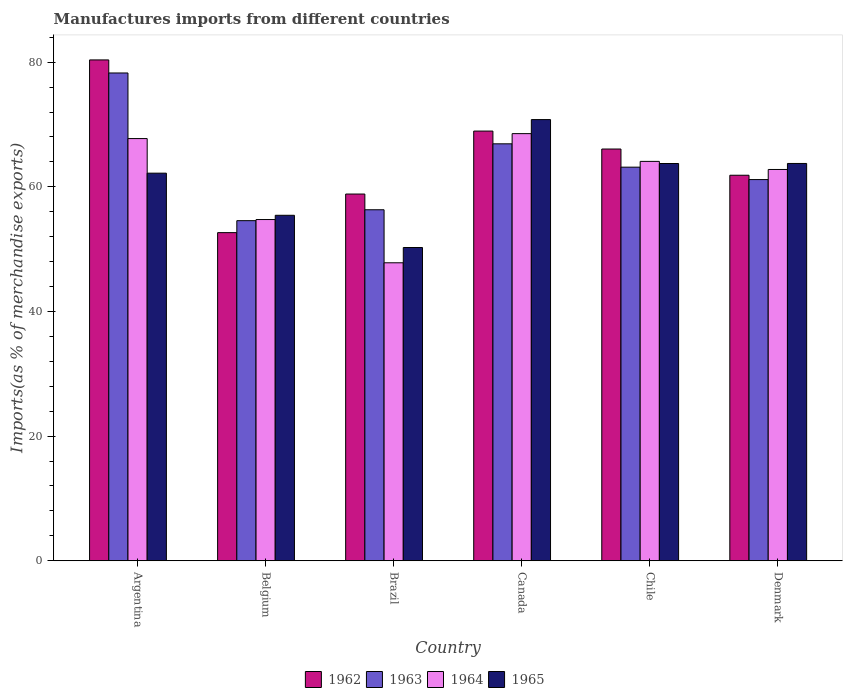How many groups of bars are there?
Make the answer very short. 6. Are the number of bars per tick equal to the number of legend labels?
Your answer should be compact. Yes. How many bars are there on the 4th tick from the left?
Give a very brief answer. 4. How many bars are there on the 1st tick from the right?
Offer a very short reply. 4. What is the percentage of imports to different countries in 1964 in Argentina?
Your response must be concise. 67.75. Across all countries, what is the maximum percentage of imports to different countries in 1963?
Provide a succinct answer. 78.27. Across all countries, what is the minimum percentage of imports to different countries in 1963?
Make the answer very short. 54.57. What is the total percentage of imports to different countries in 1965 in the graph?
Offer a terse response. 366.19. What is the difference between the percentage of imports to different countries in 1964 in Argentina and that in Denmark?
Your response must be concise. 4.96. What is the difference between the percentage of imports to different countries in 1964 in Brazil and the percentage of imports to different countries in 1962 in Chile?
Ensure brevity in your answer.  -18.25. What is the average percentage of imports to different countries in 1963 per country?
Your answer should be very brief. 63.4. What is the difference between the percentage of imports to different countries of/in 1964 and percentage of imports to different countries of/in 1965 in Argentina?
Offer a very short reply. 5.55. What is the ratio of the percentage of imports to different countries in 1962 in Argentina to that in Denmark?
Ensure brevity in your answer.  1.3. Is the percentage of imports to different countries in 1962 in Brazil less than that in Chile?
Give a very brief answer. Yes. Is the difference between the percentage of imports to different countries in 1964 in Brazil and Chile greater than the difference between the percentage of imports to different countries in 1965 in Brazil and Chile?
Your response must be concise. No. What is the difference between the highest and the second highest percentage of imports to different countries in 1965?
Keep it short and to the point. -7.05. What is the difference between the highest and the lowest percentage of imports to different countries in 1964?
Provide a short and direct response. 20.72. What does the 4th bar from the left in Brazil represents?
Make the answer very short. 1965. Is it the case that in every country, the sum of the percentage of imports to different countries in 1963 and percentage of imports to different countries in 1962 is greater than the percentage of imports to different countries in 1964?
Give a very brief answer. Yes. How many bars are there?
Make the answer very short. 24. How many countries are there in the graph?
Your answer should be compact. 6. What is the difference between two consecutive major ticks on the Y-axis?
Your answer should be compact. 20. How are the legend labels stacked?
Provide a short and direct response. Horizontal. What is the title of the graph?
Provide a short and direct response. Manufactures imports from different countries. Does "1997" appear as one of the legend labels in the graph?
Keep it short and to the point. No. What is the label or title of the Y-axis?
Offer a very short reply. Imports(as % of merchandise exports). What is the Imports(as % of merchandise exports) of 1962 in Argentina?
Your response must be concise. 80.37. What is the Imports(as % of merchandise exports) of 1963 in Argentina?
Your response must be concise. 78.27. What is the Imports(as % of merchandise exports) of 1964 in Argentina?
Offer a very short reply. 67.75. What is the Imports(as % of merchandise exports) of 1965 in Argentina?
Provide a succinct answer. 62.19. What is the Imports(as % of merchandise exports) of 1962 in Belgium?
Keep it short and to the point. 52.65. What is the Imports(as % of merchandise exports) in 1963 in Belgium?
Your answer should be compact. 54.57. What is the Imports(as % of merchandise exports) of 1964 in Belgium?
Keep it short and to the point. 54.75. What is the Imports(as % of merchandise exports) in 1965 in Belgium?
Ensure brevity in your answer.  55.44. What is the Imports(as % of merchandise exports) of 1962 in Brazil?
Offer a very short reply. 58.85. What is the Imports(as % of merchandise exports) in 1963 in Brazil?
Make the answer very short. 56.32. What is the Imports(as % of merchandise exports) of 1964 in Brazil?
Make the answer very short. 47.82. What is the Imports(as % of merchandise exports) of 1965 in Brazil?
Provide a short and direct response. 50.27. What is the Imports(as % of merchandise exports) in 1962 in Canada?
Provide a short and direct response. 68.95. What is the Imports(as % of merchandise exports) in 1963 in Canada?
Make the answer very short. 66.9. What is the Imports(as % of merchandise exports) in 1964 in Canada?
Provide a short and direct response. 68.54. What is the Imports(as % of merchandise exports) in 1965 in Canada?
Provide a succinct answer. 70.79. What is the Imports(as % of merchandise exports) in 1962 in Chile?
Offer a terse response. 66.07. What is the Imports(as % of merchandise exports) of 1963 in Chile?
Give a very brief answer. 63.16. What is the Imports(as % of merchandise exports) of 1964 in Chile?
Your answer should be compact. 64.09. What is the Imports(as % of merchandise exports) in 1965 in Chile?
Your answer should be very brief. 63.74. What is the Imports(as % of merchandise exports) of 1962 in Denmark?
Keep it short and to the point. 61.86. What is the Imports(as % of merchandise exports) of 1963 in Denmark?
Give a very brief answer. 61.17. What is the Imports(as % of merchandise exports) in 1964 in Denmark?
Offer a very short reply. 62.79. What is the Imports(as % of merchandise exports) of 1965 in Denmark?
Keep it short and to the point. 63.75. Across all countries, what is the maximum Imports(as % of merchandise exports) in 1962?
Ensure brevity in your answer.  80.37. Across all countries, what is the maximum Imports(as % of merchandise exports) in 1963?
Keep it short and to the point. 78.27. Across all countries, what is the maximum Imports(as % of merchandise exports) of 1964?
Make the answer very short. 68.54. Across all countries, what is the maximum Imports(as % of merchandise exports) of 1965?
Your response must be concise. 70.79. Across all countries, what is the minimum Imports(as % of merchandise exports) in 1962?
Keep it short and to the point. 52.65. Across all countries, what is the minimum Imports(as % of merchandise exports) in 1963?
Your answer should be very brief. 54.57. Across all countries, what is the minimum Imports(as % of merchandise exports) in 1964?
Make the answer very short. 47.82. Across all countries, what is the minimum Imports(as % of merchandise exports) in 1965?
Offer a very short reply. 50.27. What is the total Imports(as % of merchandise exports) of 1962 in the graph?
Provide a succinct answer. 388.75. What is the total Imports(as % of merchandise exports) in 1963 in the graph?
Your answer should be compact. 380.39. What is the total Imports(as % of merchandise exports) in 1964 in the graph?
Ensure brevity in your answer.  365.72. What is the total Imports(as % of merchandise exports) of 1965 in the graph?
Offer a terse response. 366.19. What is the difference between the Imports(as % of merchandise exports) of 1962 in Argentina and that in Belgium?
Offer a very short reply. 27.71. What is the difference between the Imports(as % of merchandise exports) in 1963 in Argentina and that in Belgium?
Provide a succinct answer. 23.7. What is the difference between the Imports(as % of merchandise exports) in 1964 in Argentina and that in Belgium?
Give a very brief answer. 12.99. What is the difference between the Imports(as % of merchandise exports) in 1965 in Argentina and that in Belgium?
Provide a short and direct response. 6.76. What is the difference between the Imports(as % of merchandise exports) in 1962 in Argentina and that in Brazil?
Give a very brief answer. 21.52. What is the difference between the Imports(as % of merchandise exports) in 1963 in Argentina and that in Brazil?
Offer a terse response. 21.95. What is the difference between the Imports(as % of merchandise exports) of 1964 in Argentina and that in Brazil?
Your response must be concise. 19.93. What is the difference between the Imports(as % of merchandise exports) of 1965 in Argentina and that in Brazil?
Your answer should be very brief. 11.93. What is the difference between the Imports(as % of merchandise exports) in 1962 in Argentina and that in Canada?
Make the answer very short. 11.42. What is the difference between the Imports(as % of merchandise exports) in 1963 in Argentina and that in Canada?
Ensure brevity in your answer.  11.37. What is the difference between the Imports(as % of merchandise exports) of 1964 in Argentina and that in Canada?
Provide a succinct answer. -0.79. What is the difference between the Imports(as % of merchandise exports) in 1965 in Argentina and that in Canada?
Provide a succinct answer. -8.6. What is the difference between the Imports(as % of merchandise exports) of 1962 in Argentina and that in Chile?
Your answer should be very brief. 14.3. What is the difference between the Imports(as % of merchandise exports) in 1963 in Argentina and that in Chile?
Offer a terse response. 15.11. What is the difference between the Imports(as % of merchandise exports) of 1964 in Argentina and that in Chile?
Offer a terse response. 3.66. What is the difference between the Imports(as % of merchandise exports) of 1965 in Argentina and that in Chile?
Provide a short and direct response. -1.55. What is the difference between the Imports(as % of merchandise exports) in 1962 in Argentina and that in Denmark?
Your response must be concise. 18.5. What is the difference between the Imports(as % of merchandise exports) in 1963 in Argentina and that in Denmark?
Offer a very short reply. 17.1. What is the difference between the Imports(as % of merchandise exports) in 1964 in Argentina and that in Denmark?
Give a very brief answer. 4.96. What is the difference between the Imports(as % of merchandise exports) of 1965 in Argentina and that in Denmark?
Give a very brief answer. -1.56. What is the difference between the Imports(as % of merchandise exports) of 1962 in Belgium and that in Brazil?
Your answer should be compact. -6.19. What is the difference between the Imports(as % of merchandise exports) of 1963 in Belgium and that in Brazil?
Make the answer very short. -1.75. What is the difference between the Imports(as % of merchandise exports) of 1964 in Belgium and that in Brazil?
Your answer should be very brief. 6.94. What is the difference between the Imports(as % of merchandise exports) in 1965 in Belgium and that in Brazil?
Provide a succinct answer. 5.17. What is the difference between the Imports(as % of merchandise exports) in 1962 in Belgium and that in Canada?
Provide a short and direct response. -16.3. What is the difference between the Imports(as % of merchandise exports) of 1963 in Belgium and that in Canada?
Make the answer very short. -12.33. What is the difference between the Imports(as % of merchandise exports) in 1964 in Belgium and that in Canada?
Your answer should be very brief. -13.78. What is the difference between the Imports(as % of merchandise exports) in 1965 in Belgium and that in Canada?
Ensure brevity in your answer.  -15.36. What is the difference between the Imports(as % of merchandise exports) in 1962 in Belgium and that in Chile?
Keep it short and to the point. -13.41. What is the difference between the Imports(as % of merchandise exports) in 1963 in Belgium and that in Chile?
Keep it short and to the point. -8.59. What is the difference between the Imports(as % of merchandise exports) in 1964 in Belgium and that in Chile?
Make the answer very short. -9.33. What is the difference between the Imports(as % of merchandise exports) of 1965 in Belgium and that in Chile?
Give a very brief answer. -8.31. What is the difference between the Imports(as % of merchandise exports) in 1962 in Belgium and that in Denmark?
Your response must be concise. -9.21. What is the difference between the Imports(as % of merchandise exports) in 1963 in Belgium and that in Denmark?
Provide a short and direct response. -6.59. What is the difference between the Imports(as % of merchandise exports) of 1964 in Belgium and that in Denmark?
Your response must be concise. -8.03. What is the difference between the Imports(as % of merchandise exports) of 1965 in Belgium and that in Denmark?
Provide a succinct answer. -8.32. What is the difference between the Imports(as % of merchandise exports) of 1962 in Brazil and that in Canada?
Provide a short and direct response. -10.1. What is the difference between the Imports(as % of merchandise exports) of 1963 in Brazil and that in Canada?
Your answer should be compact. -10.58. What is the difference between the Imports(as % of merchandise exports) of 1964 in Brazil and that in Canada?
Your answer should be compact. -20.72. What is the difference between the Imports(as % of merchandise exports) of 1965 in Brazil and that in Canada?
Keep it short and to the point. -20.53. What is the difference between the Imports(as % of merchandise exports) in 1962 in Brazil and that in Chile?
Offer a very short reply. -7.22. What is the difference between the Imports(as % of merchandise exports) of 1963 in Brazil and that in Chile?
Make the answer very short. -6.84. What is the difference between the Imports(as % of merchandise exports) of 1964 in Brazil and that in Chile?
Your response must be concise. -16.27. What is the difference between the Imports(as % of merchandise exports) in 1965 in Brazil and that in Chile?
Offer a very short reply. -13.48. What is the difference between the Imports(as % of merchandise exports) of 1962 in Brazil and that in Denmark?
Your answer should be very brief. -3.01. What is the difference between the Imports(as % of merchandise exports) in 1963 in Brazil and that in Denmark?
Your answer should be compact. -4.84. What is the difference between the Imports(as % of merchandise exports) in 1964 in Brazil and that in Denmark?
Make the answer very short. -14.97. What is the difference between the Imports(as % of merchandise exports) in 1965 in Brazil and that in Denmark?
Offer a terse response. -13.49. What is the difference between the Imports(as % of merchandise exports) in 1962 in Canada and that in Chile?
Provide a short and direct response. 2.88. What is the difference between the Imports(as % of merchandise exports) in 1963 in Canada and that in Chile?
Offer a very short reply. 3.74. What is the difference between the Imports(as % of merchandise exports) in 1964 in Canada and that in Chile?
Keep it short and to the point. 4.45. What is the difference between the Imports(as % of merchandise exports) in 1965 in Canada and that in Chile?
Your response must be concise. 7.05. What is the difference between the Imports(as % of merchandise exports) in 1962 in Canada and that in Denmark?
Your answer should be compact. 7.09. What is the difference between the Imports(as % of merchandise exports) in 1963 in Canada and that in Denmark?
Your response must be concise. 5.74. What is the difference between the Imports(as % of merchandise exports) in 1964 in Canada and that in Denmark?
Give a very brief answer. 5.75. What is the difference between the Imports(as % of merchandise exports) in 1965 in Canada and that in Denmark?
Your response must be concise. 7.04. What is the difference between the Imports(as % of merchandise exports) of 1962 in Chile and that in Denmark?
Provide a succinct answer. 4.21. What is the difference between the Imports(as % of merchandise exports) of 1963 in Chile and that in Denmark?
Offer a very short reply. 1.99. What is the difference between the Imports(as % of merchandise exports) of 1964 in Chile and that in Denmark?
Offer a terse response. 1.3. What is the difference between the Imports(as % of merchandise exports) in 1965 in Chile and that in Denmark?
Your response must be concise. -0.01. What is the difference between the Imports(as % of merchandise exports) of 1962 in Argentina and the Imports(as % of merchandise exports) of 1963 in Belgium?
Provide a short and direct response. 25.79. What is the difference between the Imports(as % of merchandise exports) of 1962 in Argentina and the Imports(as % of merchandise exports) of 1964 in Belgium?
Provide a short and direct response. 25.61. What is the difference between the Imports(as % of merchandise exports) in 1962 in Argentina and the Imports(as % of merchandise exports) in 1965 in Belgium?
Make the answer very short. 24.93. What is the difference between the Imports(as % of merchandise exports) of 1963 in Argentina and the Imports(as % of merchandise exports) of 1964 in Belgium?
Offer a very short reply. 23.52. What is the difference between the Imports(as % of merchandise exports) in 1963 in Argentina and the Imports(as % of merchandise exports) in 1965 in Belgium?
Ensure brevity in your answer.  22.83. What is the difference between the Imports(as % of merchandise exports) in 1964 in Argentina and the Imports(as % of merchandise exports) in 1965 in Belgium?
Provide a short and direct response. 12.31. What is the difference between the Imports(as % of merchandise exports) of 1962 in Argentina and the Imports(as % of merchandise exports) of 1963 in Brazil?
Provide a short and direct response. 24.04. What is the difference between the Imports(as % of merchandise exports) of 1962 in Argentina and the Imports(as % of merchandise exports) of 1964 in Brazil?
Your answer should be very brief. 32.55. What is the difference between the Imports(as % of merchandise exports) in 1962 in Argentina and the Imports(as % of merchandise exports) in 1965 in Brazil?
Your answer should be compact. 30.1. What is the difference between the Imports(as % of merchandise exports) in 1963 in Argentina and the Imports(as % of merchandise exports) in 1964 in Brazil?
Your answer should be very brief. 30.45. What is the difference between the Imports(as % of merchandise exports) in 1963 in Argentina and the Imports(as % of merchandise exports) in 1965 in Brazil?
Offer a very short reply. 28. What is the difference between the Imports(as % of merchandise exports) of 1964 in Argentina and the Imports(as % of merchandise exports) of 1965 in Brazil?
Provide a short and direct response. 17.48. What is the difference between the Imports(as % of merchandise exports) in 1962 in Argentina and the Imports(as % of merchandise exports) in 1963 in Canada?
Provide a succinct answer. 13.46. What is the difference between the Imports(as % of merchandise exports) of 1962 in Argentina and the Imports(as % of merchandise exports) of 1964 in Canada?
Provide a short and direct response. 11.83. What is the difference between the Imports(as % of merchandise exports) of 1962 in Argentina and the Imports(as % of merchandise exports) of 1965 in Canada?
Ensure brevity in your answer.  9.57. What is the difference between the Imports(as % of merchandise exports) of 1963 in Argentina and the Imports(as % of merchandise exports) of 1964 in Canada?
Your response must be concise. 9.73. What is the difference between the Imports(as % of merchandise exports) in 1963 in Argentina and the Imports(as % of merchandise exports) in 1965 in Canada?
Ensure brevity in your answer.  7.48. What is the difference between the Imports(as % of merchandise exports) of 1964 in Argentina and the Imports(as % of merchandise exports) of 1965 in Canada?
Make the answer very short. -3.05. What is the difference between the Imports(as % of merchandise exports) of 1962 in Argentina and the Imports(as % of merchandise exports) of 1963 in Chile?
Your answer should be compact. 17.21. What is the difference between the Imports(as % of merchandise exports) of 1962 in Argentina and the Imports(as % of merchandise exports) of 1964 in Chile?
Offer a very short reply. 16.28. What is the difference between the Imports(as % of merchandise exports) of 1962 in Argentina and the Imports(as % of merchandise exports) of 1965 in Chile?
Make the answer very short. 16.62. What is the difference between the Imports(as % of merchandise exports) in 1963 in Argentina and the Imports(as % of merchandise exports) in 1964 in Chile?
Provide a succinct answer. 14.18. What is the difference between the Imports(as % of merchandise exports) in 1963 in Argentina and the Imports(as % of merchandise exports) in 1965 in Chile?
Offer a terse response. 14.53. What is the difference between the Imports(as % of merchandise exports) of 1964 in Argentina and the Imports(as % of merchandise exports) of 1965 in Chile?
Make the answer very short. 4. What is the difference between the Imports(as % of merchandise exports) in 1962 in Argentina and the Imports(as % of merchandise exports) in 1963 in Denmark?
Offer a very short reply. 19.2. What is the difference between the Imports(as % of merchandise exports) of 1962 in Argentina and the Imports(as % of merchandise exports) of 1964 in Denmark?
Offer a very short reply. 17.58. What is the difference between the Imports(as % of merchandise exports) of 1962 in Argentina and the Imports(as % of merchandise exports) of 1965 in Denmark?
Offer a very short reply. 16.61. What is the difference between the Imports(as % of merchandise exports) of 1963 in Argentina and the Imports(as % of merchandise exports) of 1964 in Denmark?
Your answer should be very brief. 15.48. What is the difference between the Imports(as % of merchandise exports) of 1963 in Argentina and the Imports(as % of merchandise exports) of 1965 in Denmark?
Keep it short and to the point. 14.52. What is the difference between the Imports(as % of merchandise exports) in 1964 in Argentina and the Imports(as % of merchandise exports) in 1965 in Denmark?
Offer a very short reply. 3.99. What is the difference between the Imports(as % of merchandise exports) in 1962 in Belgium and the Imports(as % of merchandise exports) in 1963 in Brazil?
Provide a succinct answer. -3.67. What is the difference between the Imports(as % of merchandise exports) in 1962 in Belgium and the Imports(as % of merchandise exports) in 1964 in Brazil?
Provide a short and direct response. 4.84. What is the difference between the Imports(as % of merchandise exports) in 1962 in Belgium and the Imports(as % of merchandise exports) in 1965 in Brazil?
Offer a very short reply. 2.39. What is the difference between the Imports(as % of merchandise exports) in 1963 in Belgium and the Imports(as % of merchandise exports) in 1964 in Brazil?
Provide a short and direct response. 6.76. What is the difference between the Imports(as % of merchandise exports) of 1963 in Belgium and the Imports(as % of merchandise exports) of 1965 in Brazil?
Keep it short and to the point. 4.31. What is the difference between the Imports(as % of merchandise exports) in 1964 in Belgium and the Imports(as % of merchandise exports) in 1965 in Brazil?
Your answer should be very brief. 4.49. What is the difference between the Imports(as % of merchandise exports) in 1962 in Belgium and the Imports(as % of merchandise exports) in 1963 in Canada?
Offer a terse response. -14.25. What is the difference between the Imports(as % of merchandise exports) in 1962 in Belgium and the Imports(as % of merchandise exports) in 1964 in Canada?
Keep it short and to the point. -15.88. What is the difference between the Imports(as % of merchandise exports) of 1962 in Belgium and the Imports(as % of merchandise exports) of 1965 in Canada?
Provide a succinct answer. -18.14. What is the difference between the Imports(as % of merchandise exports) in 1963 in Belgium and the Imports(as % of merchandise exports) in 1964 in Canada?
Your answer should be very brief. -13.96. What is the difference between the Imports(as % of merchandise exports) of 1963 in Belgium and the Imports(as % of merchandise exports) of 1965 in Canada?
Offer a terse response. -16.22. What is the difference between the Imports(as % of merchandise exports) in 1964 in Belgium and the Imports(as % of merchandise exports) in 1965 in Canada?
Make the answer very short. -16.04. What is the difference between the Imports(as % of merchandise exports) in 1962 in Belgium and the Imports(as % of merchandise exports) in 1963 in Chile?
Ensure brevity in your answer.  -10.51. What is the difference between the Imports(as % of merchandise exports) of 1962 in Belgium and the Imports(as % of merchandise exports) of 1964 in Chile?
Your answer should be very brief. -11.43. What is the difference between the Imports(as % of merchandise exports) of 1962 in Belgium and the Imports(as % of merchandise exports) of 1965 in Chile?
Ensure brevity in your answer.  -11.09. What is the difference between the Imports(as % of merchandise exports) in 1963 in Belgium and the Imports(as % of merchandise exports) in 1964 in Chile?
Provide a succinct answer. -9.51. What is the difference between the Imports(as % of merchandise exports) of 1963 in Belgium and the Imports(as % of merchandise exports) of 1965 in Chile?
Ensure brevity in your answer.  -9.17. What is the difference between the Imports(as % of merchandise exports) of 1964 in Belgium and the Imports(as % of merchandise exports) of 1965 in Chile?
Offer a very short reply. -8.99. What is the difference between the Imports(as % of merchandise exports) in 1962 in Belgium and the Imports(as % of merchandise exports) in 1963 in Denmark?
Your response must be concise. -8.51. What is the difference between the Imports(as % of merchandise exports) of 1962 in Belgium and the Imports(as % of merchandise exports) of 1964 in Denmark?
Provide a succinct answer. -10.13. What is the difference between the Imports(as % of merchandise exports) of 1962 in Belgium and the Imports(as % of merchandise exports) of 1965 in Denmark?
Offer a terse response. -11.1. What is the difference between the Imports(as % of merchandise exports) in 1963 in Belgium and the Imports(as % of merchandise exports) in 1964 in Denmark?
Offer a terse response. -8.21. What is the difference between the Imports(as % of merchandise exports) of 1963 in Belgium and the Imports(as % of merchandise exports) of 1965 in Denmark?
Provide a succinct answer. -9.18. What is the difference between the Imports(as % of merchandise exports) of 1964 in Belgium and the Imports(as % of merchandise exports) of 1965 in Denmark?
Make the answer very short. -9. What is the difference between the Imports(as % of merchandise exports) in 1962 in Brazil and the Imports(as % of merchandise exports) in 1963 in Canada?
Offer a terse response. -8.06. What is the difference between the Imports(as % of merchandise exports) in 1962 in Brazil and the Imports(as % of merchandise exports) in 1964 in Canada?
Your answer should be compact. -9.69. What is the difference between the Imports(as % of merchandise exports) of 1962 in Brazil and the Imports(as % of merchandise exports) of 1965 in Canada?
Your answer should be compact. -11.95. What is the difference between the Imports(as % of merchandise exports) in 1963 in Brazil and the Imports(as % of merchandise exports) in 1964 in Canada?
Give a very brief answer. -12.21. What is the difference between the Imports(as % of merchandise exports) of 1963 in Brazil and the Imports(as % of merchandise exports) of 1965 in Canada?
Ensure brevity in your answer.  -14.47. What is the difference between the Imports(as % of merchandise exports) in 1964 in Brazil and the Imports(as % of merchandise exports) in 1965 in Canada?
Provide a succinct answer. -22.98. What is the difference between the Imports(as % of merchandise exports) of 1962 in Brazil and the Imports(as % of merchandise exports) of 1963 in Chile?
Provide a succinct answer. -4.31. What is the difference between the Imports(as % of merchandise exports) in 1962 in Brazil and the Imports(as % of merchandise exports) in 1964 in Chile?
Ensure brevity in your answer.  -5.24. What is the difference between the Imports(as % of merchandise exports) of 1962 in Brazil and the Imports(as % of merchandise exports) of 1965 in Chile?
Give a very brief answer. -4.9. What is the difference between the Imports(as % of merchandise exports) in 1963 in Brazil and the Imports(as % of merchandise exports) in 1964 in Chile?
Provide a succinct answer. -7.76. What is the difference between the Imports(as % of merchandise exports) in 1963 in Brazil and the Imports(as % of merchandise exports) in 1965 in Chile?
Offer a terse response. -7.42. What is the difference between the Imports(as % of merchandise exports) in 1964 in Brazil and the Imports(as % of merchandise exports) in 1965 in Chile?
Your response must be concise. -15.93. What is the difference between the Imports(as % of merchandise exports) of 1962 in Brazil and the Imports(as % of merchandise exports) of 1963 in Denmark?
Provide a short and direct response. -2.32. What is the difference between the Imports(as % of merchandise exports) in 1962 in Brazil and the Imports(as % of merchandise exports) in 1964 in Denmark?
Offer a very short reply. -3.94. What is the difference between the Imports(as % of merchandise exports) in 1962 in Brazil and the Imports(as % of merchandise exports) in 1965 in Denmark?
Offer a terse response. -4.91. What is the difference between the Imports(as % of merchandise exports) in 1963 in Brazil and the Imports(as % of merchandise exports) in 1964 in Denmark?
Your response must be concise. -6.46. What is the difference between the Imports(as % of merchandise exports) in 1963 in Brazil and the Imports(as % of merchandise exports) in 1965 in Denmark?
Give a very brief answer. -7.43. What is the difference between the Imports(as % of merchandise exports) in 1964 in Brazil and the Imports(as % of merchandise exports) in 1965 in Denmark?
Your answer should be compact. -15.94. What is the difference between the Imports(as % of merchandise exports) in 1962 in Canada and the Imports(as % of merchandise exports) in 1963 in Chile?
Give a very brief answer. 5.79. What is the difference between the Imports(as % of merchandise exports) of 1962 in Canada and the Imports(as % of merchandise exports) of 1964 in Chile?
Provide a short and direct response. 4.86. What is the difference between the Imports(as % of merchandise exports) in 1962 in Canada and the Imports(as % of merchandise exports) in 1965 in Chile?
Make the answer very short. 5.21. What is the difference between the Imports(as % of merchandise exports) in 1963 in Canada and the Imports(as % of merchandise exports) in 1964 in Chile?
Your response must be concise. 2.82. What is the difference between the Imports(as % of merchandise exports) in 1963 in Canada and the Imports(as % of merchandise exports) in 1965 in Chile?
Offer a very short reply. 3.16. What is the difference between the Imports(as % of merchandise exports) of 1964 in Canada and the Imports(as % of merchandise exports) of 1965 in Chile?
Offer a very short reply. 4.79. What is the difference between the Imports(as % of merchandise exports) in 1962 in Canada and the Imports(as % of merchandise exports) in 1963 in Denmark?
Ensure brevity in your answer.  7.78. What is the difference between the Imports(as % of merchandise exports) in 1962 in Canada and the Imports(as % of merchandise exports) in 1964 in Denmark?
Offer a very short reply. 6.16. What is the difference between the Imports(as % of merchandise exports) in 1962 in Canada and the Imports(as % of merchandise exports) in 1965 in Denmark?
Your answer should be compact. 5.2. What is the difference between the Imports(as % of merchandise exports) of 1963 in Canada and the Imports(as % of merchandise exports) of 1964 in Denmark?
Provide a short and direct response. 4.12. What is the difference between the Imports(as % of merchandise exports) in 1963 in Canada and the Imports(as % of merchandise exports) in 1965 in Denmark?
Provide a succinct answer. 3.15. What is the difference between the Imports(as % of merchandise exports) in 1964 in Canada and the Imports(as % of merchandise exports) in 1965 in Denmark?
Your answer should be very brief. 4.78. What is the difference between the Imports(as % of merchandise exports) of 1962 in Chile and the Imports(as % of merchandise exports) of 1963 in Denmark?
Provide a succinct answer. 4.9. What is the difference between the Imports(as % of merchandise exports) in 1962 in Chile and the Imports(as % of merchandise exports) in 1964 in Denmark?
Provide a succinct answer. 3.28. What is the difference between the Imports(as % of merchandise exports) of 1962 in Chile and the Imports(as % of merchandise exports) of 1965 in Denmark?
Provide a short and direct response. 2.31. What is the difference between the Imports(as % of merchandise exports) in 1963 in Chile and the Imports(as % of merchandise exports) in 1964 in Denmark?
Provide a short and direct response. 0.37. What is the difference between the Imports(as % of merchandise exports) in 1963 in Chile and the Imports(as % of merchandise exports) in 1965 in Denmark?
Offer a very short reply. -0.59. What is the difference between the Imports(as % of merchandise exports) in 1964 in Chile and the Imports(as % of merchandise exports) in 1965 in Denmark?
Provide a short and direct response. 0.33. What is the average Imports(as % of merchandise exports) of 1962 per country?
Make the answer very short. 64.79. What is the average Imports(as % of merchandise exports) in 1963 per country?
Give a very brief answer. 63.4. What is the average Imports(as % of merchandise exports) in 1964 per country?
Ensure brevity in your answer.  60.95. What is the average Imports(as % of merchandise exports) in 1965 per country?
Your answer should be compact. 61.03. What is the difference between the Imports(as % of merchandise exports) of 1962 and Imports(as % of merchandise exports) of 1963 in Argentina?
Give a very brief answer. 2.1. What is the difference between the Imports(as % of merchandise exports) in 1962 and Imports(as % of merchandise exports) in 1964 in Argentina?
Provide a succinct answer. 12.62. What is the difference between the Imports(as % of merchandise exports) of 1962 and Imports(as % of merchandise exports) of 1965 in Argentina?
Your response must be concise. 18.17. What is the difference between the Imports(as % of merchandise exports) of 1963 and Imports(as % of merchandise exports) of 1964 in Argentina?
Provide a succinct answer. 10.52. What is the difference between the Imports(as % of merchandise exports) in 1963 and Imports(as % of merchandise exports) in 1965 in Argentina?
Offer a very short reply. 16.08. What is the difference between the Imports(as % of merchandise exports) of 1964 and Imports(as % of merchandise exports) of 1965 in Argentina?
Offer a terse response. 5.55. What is the difference between the Imports(as % of merchandise exports) of 1962 and Imports(as % of merchandise exports) of 1963 in Belgium?
Keep it short and to the point. -1.92. What is the difference between the Imports(as % of merchandise exports) in 1962 and Imports(as % of merchandise exports) in 1964 in Belgium?
Offer a terse response. -2.1. What is the difference between the Imports(as % of merchandise exports) of 1962 and Imports(as % of merchandise exports) of 1965 in Belgium?
Offer a terse response. -2.78. What is the difference between the Imports(as % of merchandise exports) of 1963 and Imports(as % of merchandise exports) of 1964 in Belgium?
Give a very brief answer. -0.18. What is the difference between the Imports(as % of merchandise exports) of 1963 and Imports(as % of merchandise exports) of 1965 in Belgium?
Keep it short and to the point. -0.86. What is the difference between the Imports(as % of merchandise exports) of 1964 and Imports(as % of merchandise exports) of 1965 in Belgium?
Offer a terse response. -0.68. What is the difference between the Imports(as % of merchandise exports) in 1962 and Imports(as % of merchandise exports) in 1963 in Brazil?
Your response must be concise. 2.52. What is the difference between the Imports(as % of merchandise exports) in 1962 and Imports(as % of merchandise exports) in 1964 in Brazil?
Make the answer very short. 11.03. What is the difference between the Imports(as % of merchandise exports) in 1962 and Imports(as % of merchandise exports) in 1965 in Brazil?
Offer a terse response. 8.58. What is the difference between the Imports(as % of merchandise exports) of 1963 and Imports(as % of merchandise exports) of 1964 in Brazil?
Keep it short and to the point. 8.51. What is the difference between the Imports(as % of merchandise exports) of 1963 and Imports(as % of merchandise exports) of 1965 in Brazil?
Ensure brevity in your answer.  6.06. What is the difference between the Imports(as % of merchandise exports) of 1964 and Imports(as % of merchandise exports) of 1965 in Brazil?
Offer a very short reply. -2.45. What is the difference between the Imports(as % of merchandise exports) of 1962 and Imports(as % of merchandise exports) of 1963 in Canada?
Keep it short and to the point. 2.05. What is the difference between the Imports(as % of merchandise exports) of 1962 and Imports(as % of merchandise exports) of 1964 in Canada?
Give a very brief answer. 0.41. What is the difference between the Imports(as % of merchandise exports) in 1962 and Imports(as % of merchandise exports) in 1965 in Canada?
Ensure brevity in your answer.  -1.84. What is the difference between the Imports(as % of merchandise exports) of 1963 and Imports(as % of merchandise exports) of 1964 in Canada?
Your answer should be very brief. -1.64. What is the difference between the Imports(as % of merchandise exports) of 1963 and Imports(as % of merchandise exports) of 1965 in Canada?
Ensure brevity in your answer.  -3.89. What is the difference between the Imports(as % of merchandise exports) of 1964 and Imports(as % of merchandise exports) of 1965 in Canada?
Provide a short and direct response. -2.26. What is the difference between the Imports(as % of merchandise exports) in 1962 and Imports(as % of merchandise exports) in 1963 in Chile?
Give a very brief answer. 2.91. What is the difference between the Imports(as % of merchandise exports) in 1962 and Imports(as % of merchandise exports) in 1964 in Chile?
Keep it short and to the point. 1.98. What is the difference between the Imports(as % of merchandise exports) in 1962 and Imports(as % of merchandise exports) in 1965 in Chile?
Make the answer very short. 2.32. What is the difference between the Imports(as % of merchandise exports) in 1963 and Imports(as % of merchandise exports) in 1964 in Chile?
Make the answer very short. -0.93. What is the difference between the Imports(as % of merchandise exports) of 1963 and Imports(as % of merchandise exports) of 1965 in Chile?
Ensure brevity in your answer.  -0.59. What is the difference between the Imports(as % of merchandise exports) of 1964 and Imports(as % of merchandise exports) of 1965 in Chile?
Your answer should be very brief. 0.34. What is the difference between the Imports(as % of merchandise exports) in 1962 and Imports(as % of merchandise exports) in 1963 in Denmark?
Provide a succinct answer. 0.69. What is the difference between the Imports(as % of merchandise exports) of 1962 and Imports(as % of merchandise exports) of 1964 in Denmark?
Give a very brief answer. -0.92. What is the difference between the Imports(as % of merchandise exports) of 1962 and Imports(as % of merchandise exports) of 1965 in Denmark?
Give a very brief answer. -1.89. What is the difference between the Imports(as % of merchandise exports) of 1963 and Imports(as % of merchandise exports) of 1964 in Denmark?
Provide a succinct answer. -1.62. What is the difference between the Imports(as % of merchandise exports) of 1963 and Imports(as % of merchandise exports) of 1965 in Denmark?
Your answer should be compact. -2.59. What is the difference between the Imports(as % of merchandise exports) in 1964 and Imports(as % of merchandise exports) in 1965 in Denmark?
Your response must be concise. -0.97. What is the ratio of the Imports(as % of merchandise exports) in 1962 in Argentina to that in Belgium?
Offer a very short reply. 1.53. What is the ratio of the Imports(as % of merchandise exports) in 1963 in Argentina to that in Belgium?
Your response must be concise. 1.43. What is the ratio of the Imports(as % of merchandise exports) of 1964 in Argentina to that in Belgium?
Your response must be concise. 1.24. What is the ratio of the Imports(as % of merchandise exports) of 1965 in Argentina to that in Belgium?
Provide a succinct answer. 1.12. What is the ratio of the Imports(as % of merchandise exports) in 1962 in Argentina to that in Brazil?
Your answer should be compact. 1.37. What is the ratio of the Imports(as % of merchandise exports) of 1963 in Argentina to that in Brazil?
Give a very brief answer. 1.39. What is the ratio of the Imports(as % of merchandise exports) in 1964 in Argentina to that in Brazil?
Provide a succinct answer. 1.42. What is the ratio of the Imports(as % of merchandise exports) in 1965 in Argentina to that in Brazil?
Ensure brevity in your answer.  1.24. What is the ratio of the Imports(as % of merchandise exports) of 1962 in Argentina to that in Canada?
Provide a succinct answer. 1.17. What is the ratio of the Imports(as % of merchandise exports) of 1963 in Argentina to that in Canada?
Offer a terse response. 1.17. What is the ratio of the Imports(as % of merchandise exports) of 1964 in Argentina to that in Canada?
Your answer should be very brief. 0.99. What is the ratio of the Imports(as % of merchandise exports) of 1965 in Argentina to that in Canada?
Keep it short and to the point. 0.88. What is the ratio of the Imports(as % of merchandise exports) in 1962 in Argentina to that in Chile?
Offer a very short reply. 1.22. What is the ratio of the Imports(as % of merchandise exports) of 1963 in Argentina to that in Chile?
Ensure brevity in your answer.  1.24. What is the ratio of the Imports(as % of merchandise exports) in 1964 in Argentina to that in Chile?
Keep it short and to the point. 1.06. What is the ratio of the Imports(as % of merchandise exports) of 1965 in Argentina to that in Chile?
Provide a succinct answer. 0.98. What is the ratio of the Imports(as % of merchandise exports) in 1962 in Argentina to that in Denmark?
Offer a very short reply. 1.3. What is the ratio of the Imports(as % of merchandise exports) in 1963 in Argentina to that in Denmark?
Your answer should be very brief. 1.28. What is the ratio of the Imports(as % of merchandise exports) in 1964 in Argentina to that in Denmark?
Your answer should be very brief. 1.08. What is the ratio of the Imports(as % of merchandise exports) of 1965 in Argentina to that in Denmark?
Keep it short and to the point. 0.98. What is the ratio of the Imports(as % of merchandise exports) in 1962 in Belgium to that in Brazil?
Keep it short and to the point. 0.89. What is the ratio of the Imports(as % of merchandise exports) in 1963 in Belgium to that in Brazil?
Your response must be concise. 0.97. What is the ratio of the Imports(as % of merchandise exports) in 1964 in Belgium to that in Brazil?
Provide a short and direct response. 1.15. What is the ratio of the Imports(as % of merchandise exports) of 1965 in Belgium to that in Brazil?
Keep it short and to the point. 1.1. What is the ratio of the Imports(as % of merchandise exports) in 1962 in Belgium to that in Canada?
Offer a terse response. 0.76. What is the ratio of the Imports(as % of merchandise exports) of 1963 in Belgium to that in Canada?
Give a very brief answer. 0.82. What is the ratio of the Imports(as % of merchandise exports) in 1964 in Belgium to that in Canada?
Provide a succinct answer. 0.8. What is the ratio of the Imports(as % of merchandise exports) of 1965 in Belgium to that in Canada?
Keep it short and to the point. 0.78. What is the ratio of the Imports(as % of merchandise exports) in 1962 in Belgium to that in Chile?
Make the answer very short. 0.8. What is the ratio of the Imports(as % of merchandise exports) in 1963 in Belgium to that in Chile?
Ensure brevity in your answer.  0.86. What is the ratio of the Imports(as % of merchandise exports) in 1964 in Belgium to that in Chile?
Give a very brief answer. 0.85. What is the ratio of the Imports(as % of merchandise exports) of 1965 in Belgium to that in Chile?
Keep it short and to the point. 0.87. What is the ratio of the Imports(as % of merchandise exports) of 1962 in Belgium to that in Denmark?
Offer a terse response. 0.85. What is the ratio of the Imports(as % of merchandise exports) of 1963 in Belgium to that in Denmark?
Your response must be concise. 0.89. What is the ratio of the Imports(as % of merchandise exports) of 1964 in Belgium to that in Denmark?
Your response must be concise. 0.87. What is the ratio of the Imports(as % of merchandise exports) of 1965 in Belgium to that in Denmark?
Keep it short and to the point. 0.87. What is the ratio of the Imports(as % of merchandise exports) of 1962 in Brazil to that in Canada?
Make the answer very short. 0.85. What is the ratio of the Imports(as % of merchandise exports) of 1963 in Brazil to that in Canada?
Your response must be concise. 0.84. What is the ratio of the Imports(as % of merchandise exports) of 1964 in Brazil to that in Canada?
Your response must be concise. 0.7. What is the ratio of the Imports(as % of merchandise exports) of 1965 in Brazil to that in Canada?
Provide a succinct answer. 0.71. What is the ratio of the Imports(as % of merchandise exports) of 1962 in Brazil to that in Chile?
Your answer should be compact. 0.89. What is the ratio of the Imports(as % of merchandise exports) in 1963 in Brazil to that in Chile?
Offer a terse response. 0.89. What is the ratio of the Imports(as % of merchandise exports) in 1964 in Brazil to that in Chile?
Provide a succinct answer. 0.75. What is the ratio of the Imports(as % of merchandise exports) in 1965 in Brazil to that in Chile?
Keep it short and to the point. 0.79. What is the ratio of the Imports(as % of merchandise exports) of 1962 in Brazil to that in Denmark?
Keep it short and to the point. 0.95. What is the ratio of the Imports(as % of merchandise exports) in 1963 in Brazil to that in Denmark?
Ensure brevity in your answer.  0.92. What is the ratio of the Imports(as % of merchandise exports) of 1964 in Brazil to that in Denmark?
Offer a very short reply. 0.76. What is the ratio of the Imports(as % of merchandise exports) of 1965 in Brazil to that in Denmark?
Offer a terse response. 0.79. What is the ratio of the Imports(as % of merchandise exports) of 1962 in Canada to that in Chile?
Give a very brief answer. 1.04. What is the ratio of the Imports(as % of merchandise exports) in 1963 in Canada to that in Chile?
Offer a very short reply. 1.06. What is the ratio of the Imports(as % of merchandise exports) of 1964 in Canada to that in Chile?
Make the answer very short. 1.07. What is the ratio of the Imports(as % of merchandise exports) in 1965 in Canada to that in Chile?
Offer a terse response. 1.11. What is the ratio of the Imports(as % of merchandise exports) of 1962 in Canada to that in Denmark?
Provide a short and direct response. 1.11. What is the ratio of the Imports(as % of merchandise exports) of 1963 in Canada to that in Denmark?
Your response must be concise. 1.09. What is the ratio of the Imports(as % of merchandise exports) in 1964 in Canada to that in Denmark?
Offer a terse response. 1.09. What is the ratio of the Imports(as % of merchandise exports) of 1965 in Canada to that in Denmark?
Your answer should be compact. 1.11. What is the ratio of the Imports(as % of merchandise exports) in 1962 in Chile to that in Denmark?
Your response must be concise. 1.07. What is the ratio of the Imports(as % of merchandise exports) in 1963 in Chile to that in Denmark?
Your answer should be very brief. 1.03. What is the ratio of the Imports(as % of merchandise exports) in 1964 in Chile to that in Denmark?
Your response must be concise. 1.02. What is the difference between the highest and the second highest Imports(as % of merchandise exports) in 1962?
Offer a very short reply. 11.42. What is the difference between the highest and the second highest Imports(as % of merchandise exports) of 1963?
Make the answer very short. 11.37. What is the difference between the highest and the second highest Imports(as % of merchandise exports) of 1964?
Provide a succinct answer. 0.79. What is the difference between the highest and the second highest Imports(as % of merchandise exports) of 1965?
Your answer should be very brief. 7.04. What is the difference between the highest and the lowest Imports(as % of merchandise exports) of 1962?
Offer a very short reply. 27.71. What is the difference between the highest and the lowest Imports(as % of merchandise exports) in 1963?
Give a very brief answer. 23.7. What is the difference between the highest and the lowest Imports(as % of merchandise exports) of 1964?
Your answer should be very brief. 20.72. What is the difference between the highest and the lowest Imports(as % of merchandise exports) in 1965?
Your answer should be compact. 20.53. 